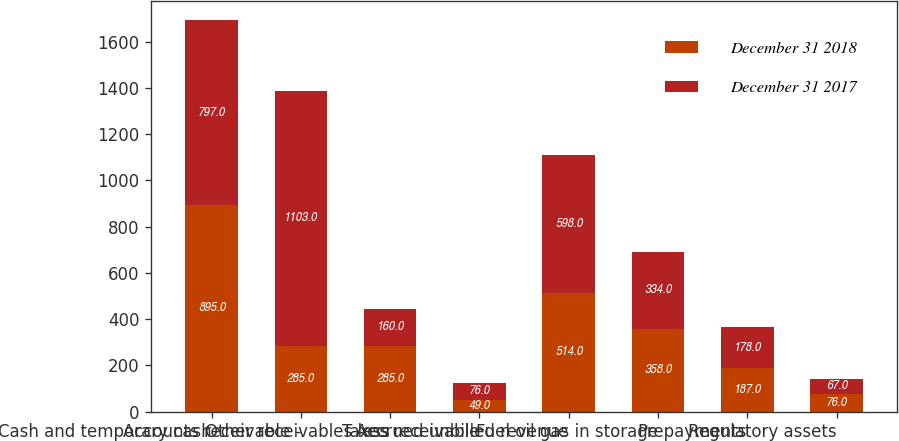Convert chart. <chart><loc_0><loc_0><loc_500><loc_500><stacked_bar_chart><ecel><fcel>Cash and temporary cash<fcel>Accounts receivable -<fcel>Other receivables less<fcel>Taxes receivable<fcel>Accrued unbilled revenue<fcel>Fuel oil gas in storage<fcel>Prepayments<fcel>Regulatory assets<nl><fcel>December 31 2018<fcel>895<fcel>285<fcel>285<fcel>49<fcel>514<fcel>358<fcel>187<fcel>76<nl><fcel>December 31 2017<fcel>797<fcel>1103<fcel>160<fcel>76<fcel>598<fcel>334<fcel>178<fcel>67<nl></chart> 